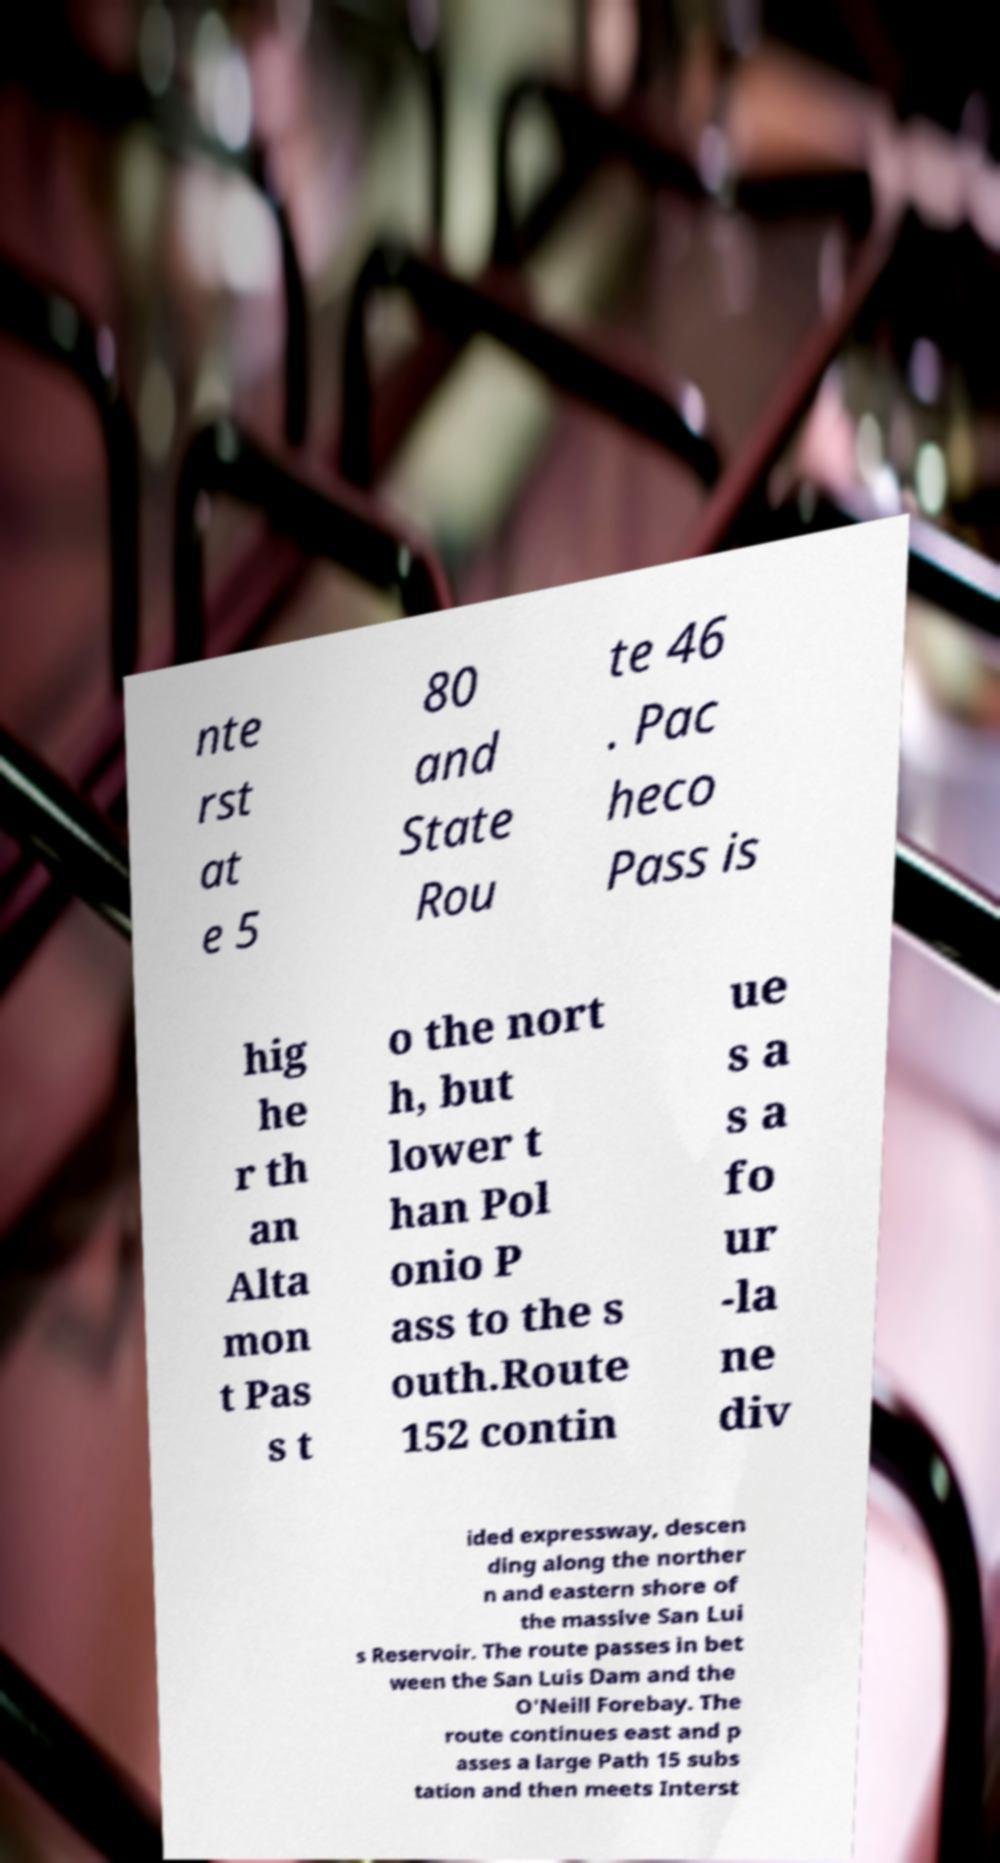There's text embedded in this image that I need extracted. Can you transcribe it verbatim? nte rst at e 5 80 and State Rou te 46 . Pac heco Pass is hig he r th an Alta mon t Pas s t o the nort h, but lower t han Pol onio P ass to the s outh.Route 152 contin ue s a s a fo ur -la ne div ided expressway, descen ding along the norther n and eastern shore of the massive San Lui s Reservoir. The route passes in bet ween the San Luis Dam and the O'Neill Forebay. The route continues east and p asses a large Path 15 subs tation and then meets Interst 